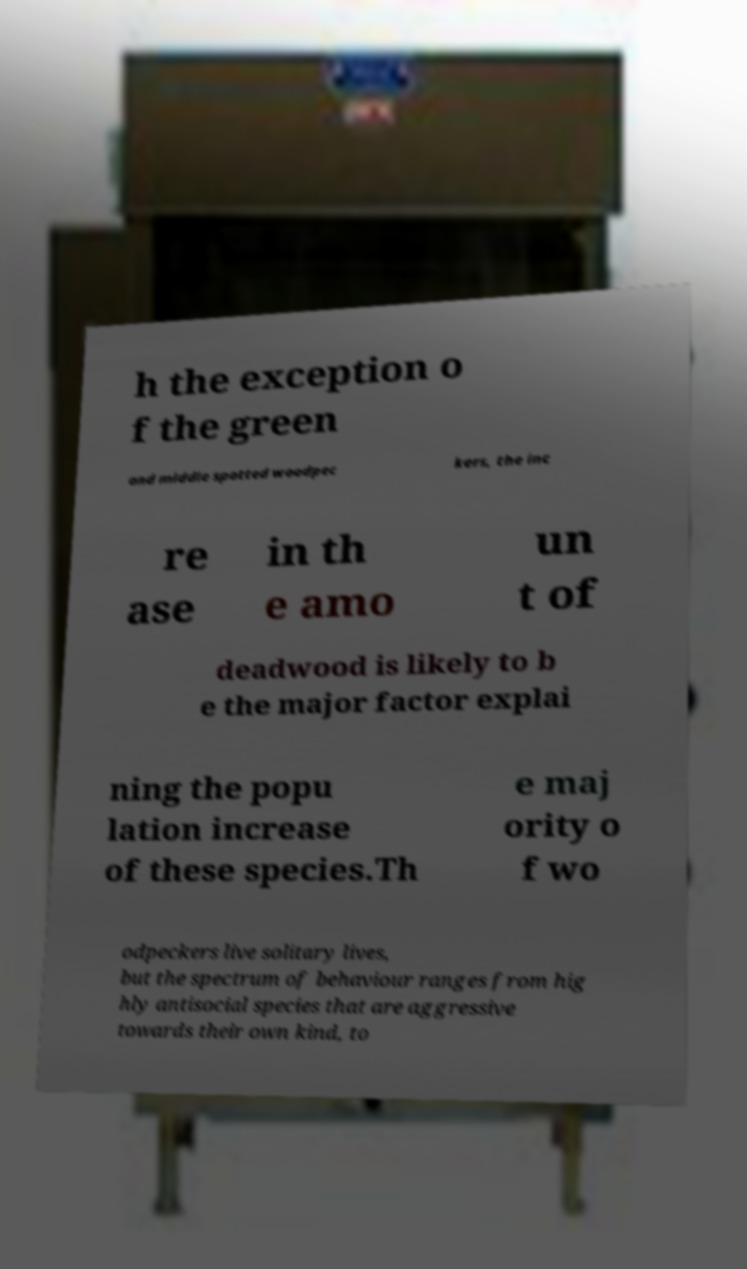I need the written content from this picture converted into text. Can you do that? h the exception o f the green and middle spotted woodpec kers, the inc re ase in th e amo un t of deadwood is likely to b e the major factor explai ning the popu lation increase of these species.Th e maj ority o f wo odpeckers live solitary lives, but the spectrum of behaviour ranges from hig hly antisocial species that are aggressive towards their own kind, to 